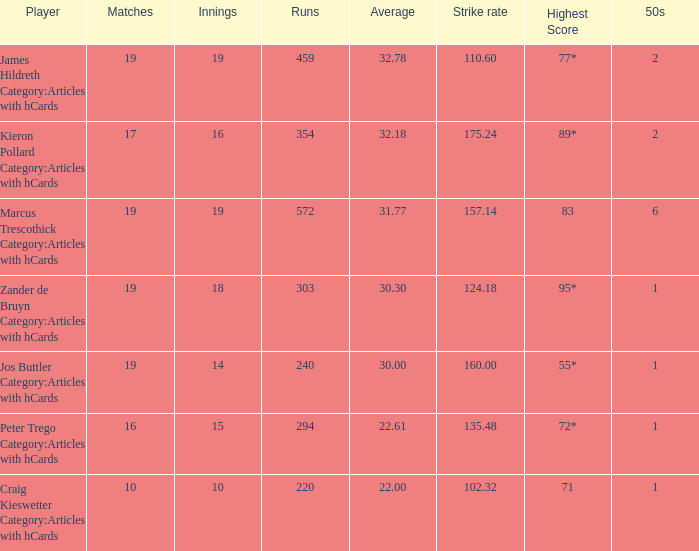How many innings for the player with an average of 22.61? 15.0. 